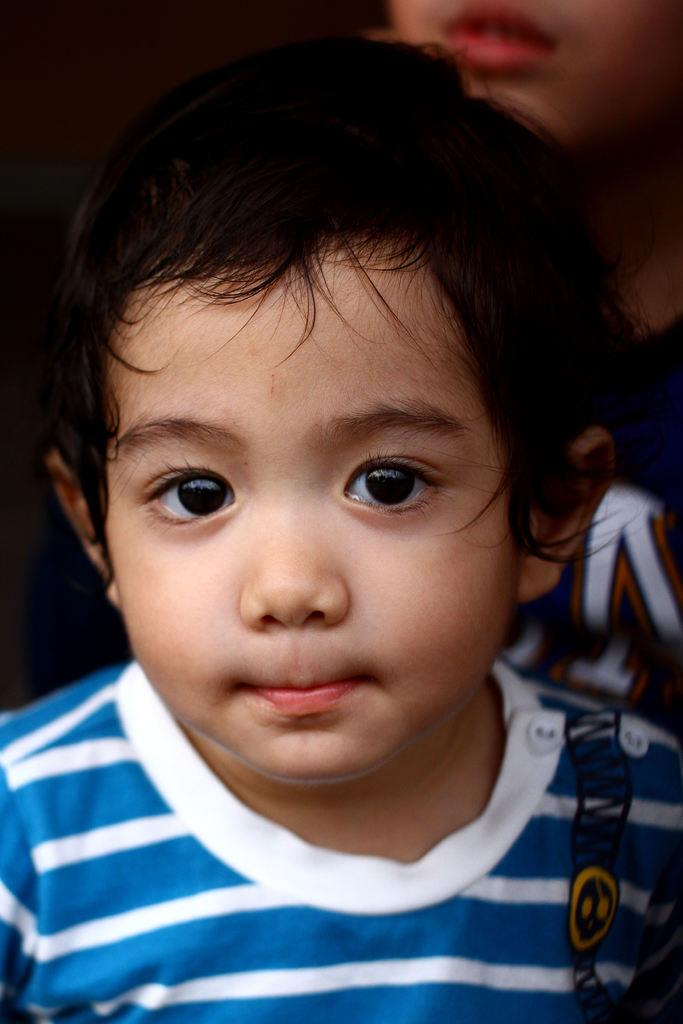Who is the main subject in the image? There is a boy in the image. What is the boy wearing? The boy is wearing a white and blue t-shirt. Can you describe the person behind the boy? There is a person at the back of the boy, but their appearance is not specified in the facts. What type of land can be seen in the image? There is no information about land in the image, as it only features a boy and another person. Are there any fairies present in the image? There is no mention of fairies in the image, as it only features a boy and another person. 